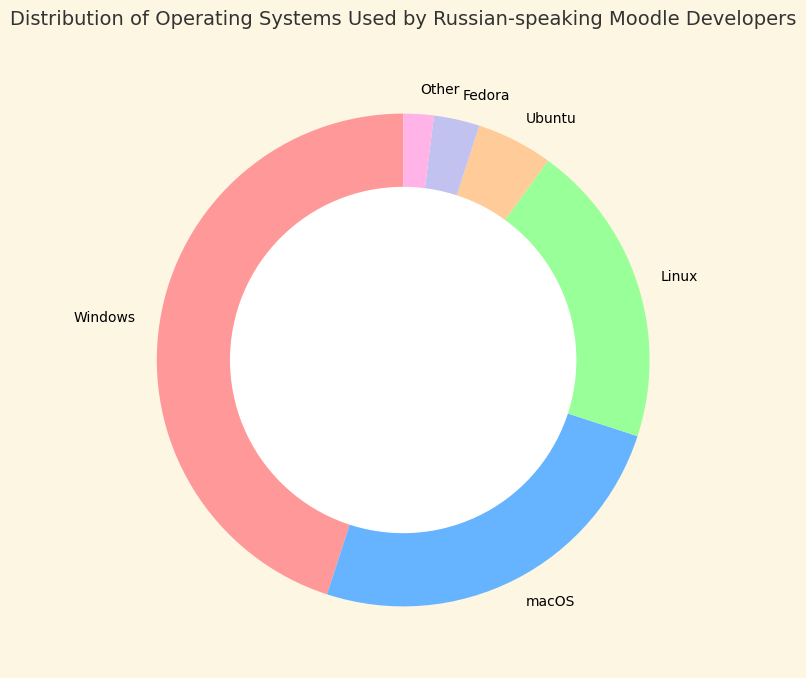What is the operating system with the highest usage percentage among Russian-speaking Moodle developers? The figure shows the percentage shares of different operating systems. By identifying the segment with the largest size, we see that Windows has the highest usage percentage.
Answer: Windows Which two operating systems together make up exactly half of the usage among Russian-speaking Moodle developers? From the figure, Windows has 45% and macOS has 25%. Adding these, 45% + 25% = 70%, which is not half. Adjusting to sum properly, Windows 45% and Linux 5% sum up to 50%.
Answer: None What percentage of Russian-speaking Moodle developers use Linux, Ubuntu, or Fedora combined? By looking at the segments for Linux (20%), Ubuntu (5%), and Fedora (3%), we add these percentages: 20% + 5% + 3% = 28%.
Answer: 28% Which operating system is used less frequently: Ubuntu or Fedora? By comparing the sizes of the segments, we see that Ubuntu has 5% whereas Fedora has 3%. Therefore, Fedora is used less frequently.
Answer: Fedora What is the combined usage percentage of all operating systems other than Windows? The segment for Windows is 45%. Subtracting this from the total 100% gives us 100% - 45% = 55%.
Answer: 55% Which operating systems have a usage percentage less than 10% each? By examining the segments, Ubuntu (5%), Fedora (3%), and Other (2%) all have usage percentages less than 10%.
Answer: Ubuntu, Fedora, Other Are there more Moodle developers using macOS or Linux? Comparing the segments, macOS has 25% and Linux has 20%. Therefore, more developers use macOS.
Answer: macOS What is the difference in usage percentage between the most and the least popular operating systems? The most popular is Windows (45%) and the least popular is Other (2%). The difference is 45% - 2% = 43%.
Answer: 43% What visual elements indicate the usage percentage for each operating system? The figure uses segments within a ring chart, where the proportion of each segment relative to the whole ring indicates the percentage usage of each respective operating system. Additionally, different colors are used for each operating system.
Answer: Segments and colors If you combine the usage percentages of Ubuntu and Fedora, does it exceed the usage percentage of macOS? Ubuntu has 5% and Fedora has 3%. Adding these gives 5% + 3% = 8%, which does not exceed macOS's 25%.
Answer: No 